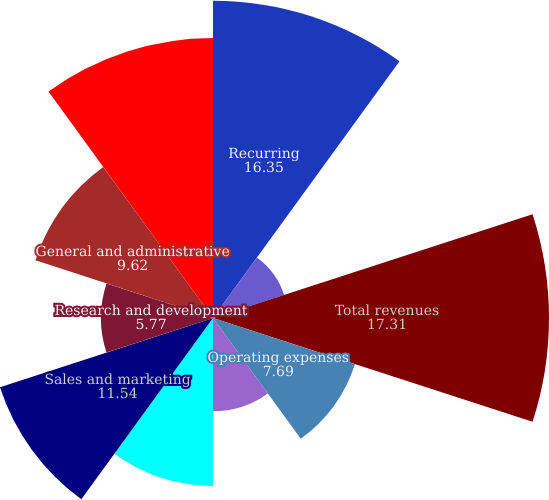Convert chart. <chart><loc_0><loc_0><loc_500><loc_500><pie_chart><fcel>Recurring<fcel>Implementation and other<fcel>Total revenues<fcel>Operating expenses<fcel>Depreciation and amortization<fcel>Total cost of revenues<fcel>Sales and marketing<fcel>Research and development<fcel>General and administrative<fcel>Total administrative expenses<nl><fcel>16.35%<fcel>3.85%<fcel>17.31%<fcel>7.69%<fcel>4.81%<fcel>8.65%<fcel>11.54%<fcel>5.77%<fcel>9.62%<fcel>14.42%<nl></chart> 